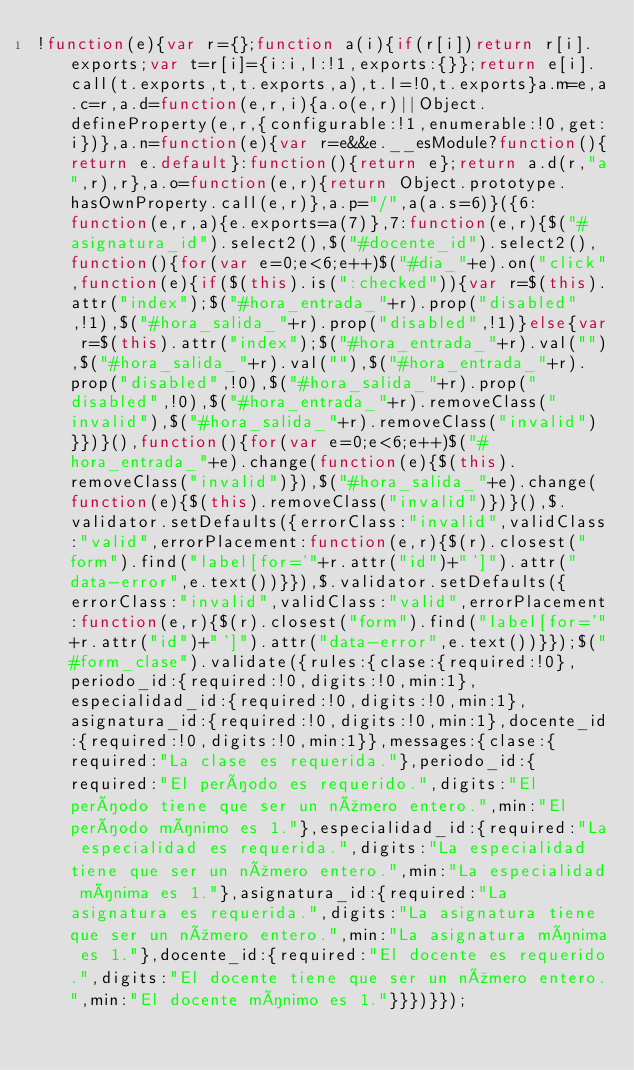Convert code to text. <code><loc_0><loc_0><loc_500><loc_500><_JavaScript_>!function(e){var r={};function a(i){if(r[i])return r[i].exports;var t=r[i]={i:i,l:!1,exports:{}};return e[i].call(t.exports,t,t.exports,a),t.l=!0,t.exports}a.m=e,a.c=r,a.d=function(e,r,i){a.o(e,r)||Object.defineProperty(e,r,{configurable:!1,enumerable:!0,get:i})},a.n=function(e){var r=e&&e.__esModule?function(){return e.default}:function(){return e};return a.d(r,"a",r),r},a.o=function(e,r){return Object.prototype.hasOwnProperty.call(e,r)},a.p="/",a(a.s=6)}({6:function(e,r,a){e.exports=a(7)},7:function(e,r){$("#asignatura_id").select2(),$("#docente_id").select2(),function(){for(var e=0;e<6;e++)$("#dia_"+e).on("click",function(e){if($(this).is(":checked")){var r=$(this).attr("index");$("#hora_entrada_"+r).prop("disabled",!1),$("#hora_salida_"+r).prop("disabled",!1)}else{var r=$(this).attr("index");$("#hora_entrada_"+r).val(""),$("#hora_salida_"+r).val(""),$("#hora_entrada_"+r).prop("disabled",!0),$("#hora_salida_"+r).prop("disabled",!0),$("#hora_entrada_"+r).removeClass("invalid"),$("#hora_salida_"+r).removeClass("invalid")}})}(),function(){for(var e=0;e<6;e++)$("#hora_entrada_"+e).change(function(e){$(this).removeClass("invalid")}),$("#hora_salida_"+e).change(function(e){$(this).removeClass("invalid")})}(),$.validator.setDefaults({errorClass:"invalid",validClass:"valid",errorPlacement:function(e,r){$(r).closest("form").find("label[for='"+r.attr("id")+"']").attr("data-error",e.text())}}),$.validator.setDefaults({errorClass:"invalid",validClass:"valid",errorPlacement:function(e,r){$(r).closest("form").find("label[for='"+r.attr("id")+"']").attr("data-error",e.text())}});$("#form_clase").validate({rules:{clase:{required:!0},periodo_id:{required:!0,digits:!0,min:1},especialidad_id:{required:!0,digits:!0,min:1},asignatura_id:{required:!0,digits:!0,min:1},docente_id:{required:!0,digits:!0,min:1}},messages:{clase:{required:"La clase es requerida."},periodo_id:{required:"El período es requerido.",digits:"El período tiene que ser un número entero.",min:"El período mínimo es 1."},especialidad_id:{required:"La especialidad es requerida.",digits:"La especialidad tiene que ser un número entero.",min:"La especialidad mínima es 1."},asignatura_id:{required:"La asignatura es requerida.",digits:"La asignatura tiene que ser un número entero.",min:"La asignatura mínima es 1."},docente_id:{required:"El docente es requerido.",digits:"El docente tiene que ser un número entero.",min:"El docente mínimo es 1."}}})}});</code> 